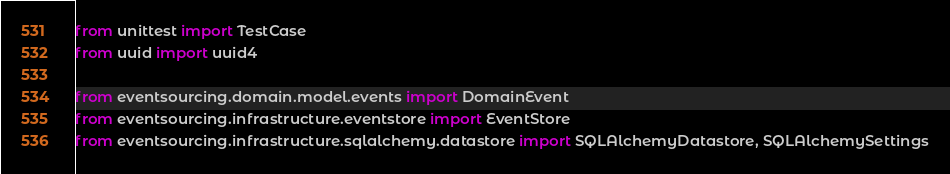<code> <loc_0><loc_0><loc_500><loc_500><_Python_>from unittest import TestCase
from uuid import uuid4

from eventsourcing.domain.model.events import DomainEvent
from eventsourcing.infrastructure.eventstore import EventStore
from eventsourcing.infrastructure.sqlalchemy.datastore import SQLAlchemyDatastore, SQLAlchemySettings</code> 